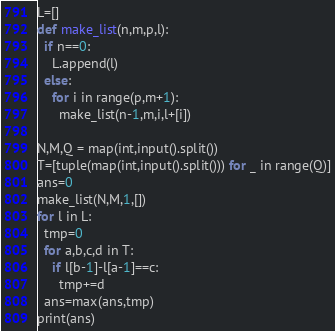Convert code to text. <code><loc_0><loc_0><loc_500><loc_500><_Python_>L=[]
def make_list(n,m,p,l):
  if n==0:
    L.append(l)
  else:
    for i in range(p,m+1):
      make_list(n-1,m,i,l+[i])
  
N,M,Q = map(int,input().split())
T=[tuple(map(int,input().split())) for _ in range(Q)]
ans=0
make_list(N,M,1,[])
for l in L:
  tmp=0
  for a,b,c,d in T:
    if l[b-1]-l[a-1]==c:
      tmp+=d
  ans=max(ans,tmp)
print(ans)</code> 